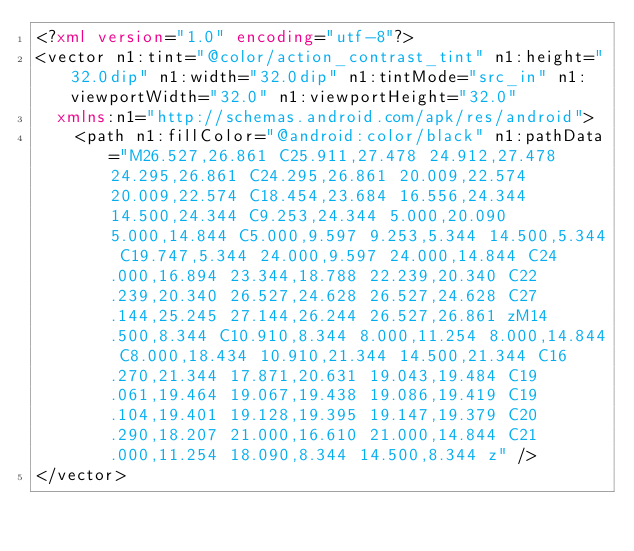<code> <loc_0><loc_0><loc_500><loc_500><_XML_><?xml version="1.0" encoding="utf-8"?>
<vector n1:tint="@color/action_contrast_tint" n1:height="32.0dip" n1:width="32.0dip" n1:tintMode="src_in" n1:viewportWidth="32.0" n1:viewportHeight="32.0"
  xmlns:n1="http://schemas.android.com/apk/res/android">
    <path n1:fillColor="@android:color/black" n1:pathData="M26.527,26.861 C25.911,27.478 24.912,27.478 24.295,26.861 C24.295,26.861 20.009,22.574 20.009,22.574 C18.454,23.684 16.556,24.344 14.500,24.344 C9.253,24.344 5.000,20.090 5.000,14.844 C5.000,9.597 9.253,5.344 14.500,5.344 C19.747,5.344 24.000,9.597 24.000,14.844 C24.000,16.894 23.344,18.788 22.239,20.340 C22.239,20.340 26.527,24.628 26.527,24.628 C27.144,25.245 27.144,26.244 26.527,26.861 zM14.500,8.344 C10.910,8.344 8.000,11.254 8.000,14.844 C8.000,18.434 10.910,21.344 14.500,21.344 C16.270,21.344 17.871,20.631 19.043,19.484 C19.061,19.464 19.067,19.438 19.086,19.419 C19.104,19.401 19.128,19.395 19.147,19.379 C20.290,18.207 21.000,16.610 21.000,14.844 C21.000,11.254 18.090,8.344 14.500,8.344 z" />
</vector></code> 